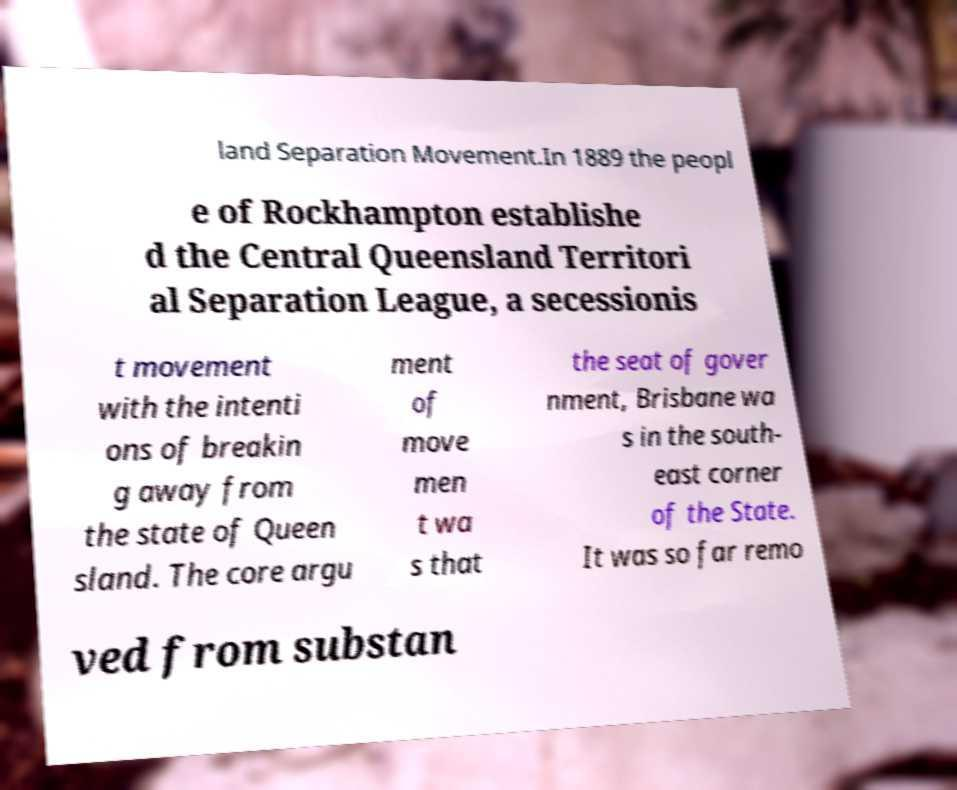For documentation purposes, I need the text within this image transcribed. Could you provide that? land Separation Movement.In 1889 the peopl e of Rockhampton establishe d the Central Queensland Territori al Separation League, a secessionis t movement with the intenti ons of breakin g away from the state of Queen sland. The core argu ment of move men t wa s that the seat of gover nment, Brisbane wa s in the south- east corner of the State. It was so far remo ved from substan 